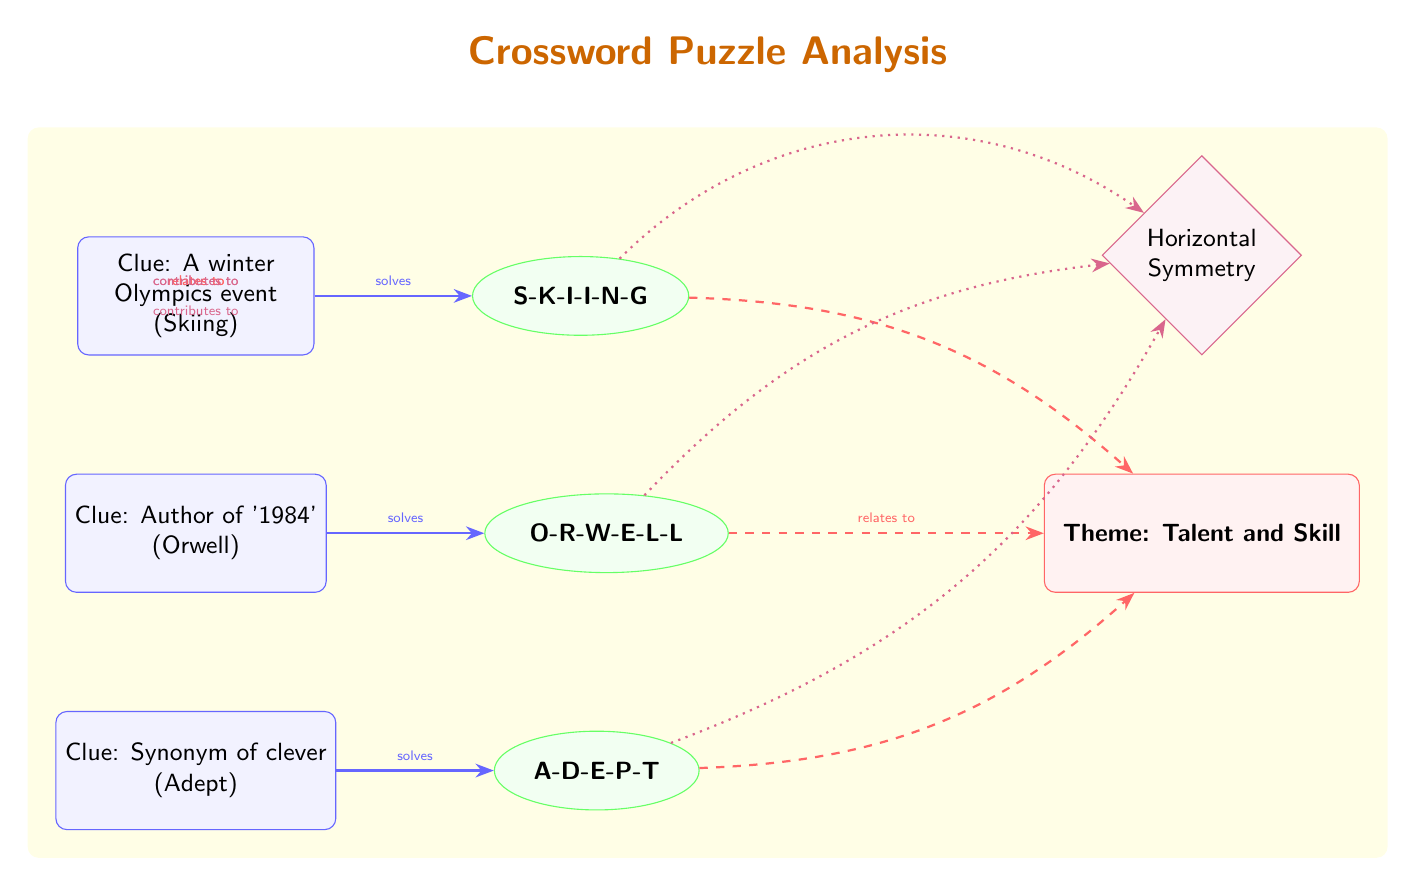What's the theme of the crossword puzzle? The diagram identifies "Talent and Skill" as the theme, indicated by the labeled node connected to the various solved words. The theme node is positioned to the right of the words and in close relation to their respective clues.
Answer: Talent and Skill How many clues are present in the diagram? There are three clues represented in the diagram, each labeled accordingly with a description and their respective answers underneath them.
Answer: 3 Which word is connected to the clue "Author of '1984'"? By examining the connections in the diagram, the word "Orwell" is linked directly to its corresponding clue. The word node corresponding to clue two indicates the answer directly next to it.
Answer: Orwell What type of symmetry does the puzzle exhibit? The diagram clearly labels the type of symmetry as "Horizontal Symmetry." This is displayed on the diagram above the theme node, indicating how the puzzle's structure is set up.
Answer: Horizontal Symmetry How do the words relate to the overall theme? Each word has a direct connection to the theme node, showing how they contribute to its meaning. The arrows labeled "relates to" indicate this relationship from each of the word nodes to the theme node.
Answer: Relates to Which word contributes to the symmetry of the puzzle? The diagram indicates that all three words contribute to the horizontal symmetry, shown by the arrows labeled "contributes to" leading from each word node to the symmetry node at the top.
Answer: All words What is the connection type between clues and solved words? The connections between clues and their solved words are indicated with arrows labeled "solves," which show a direct relationship that links each clue to its answer.
Answer: Solves Which word is a synonym of 'clever'? The diagram shows the clue for this word as "Synonym of clever," leading directly to the word node titled "Adept," which is the answer.
Answer: Adept 